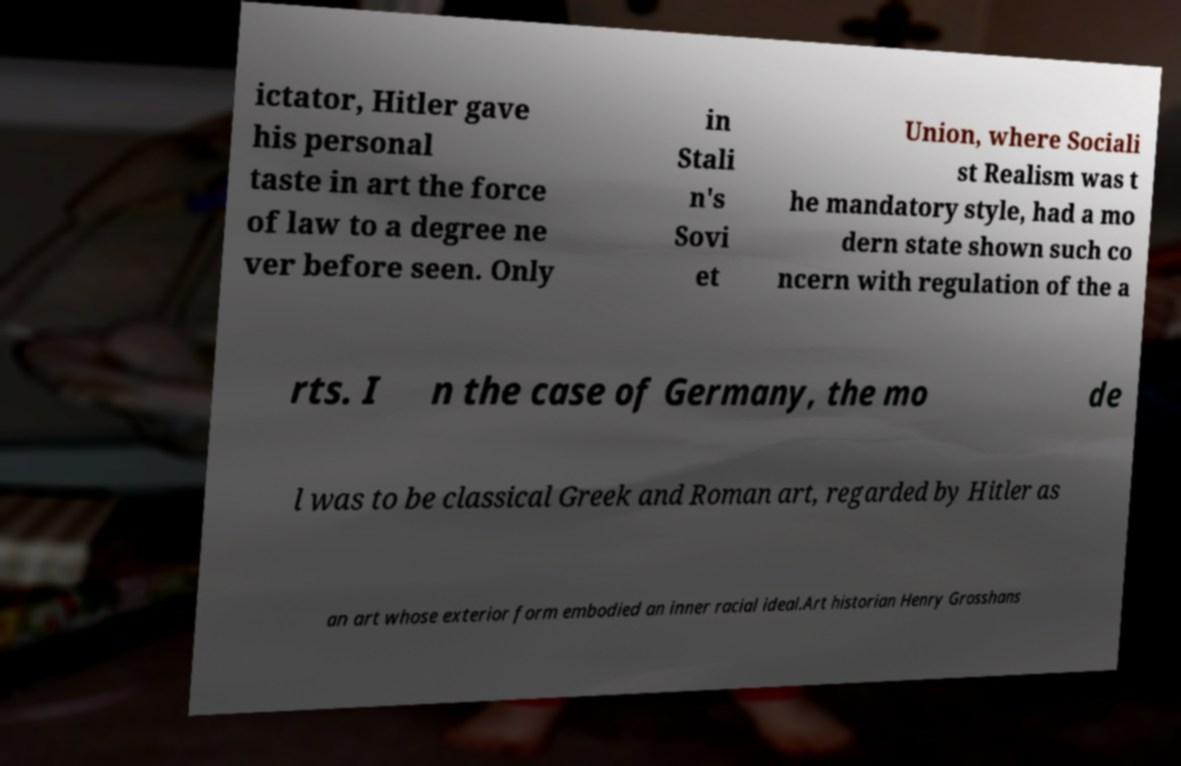What messages or text are displayed in this image? I need them in a readable, typed format. ictator, Hitler gave his personal taste in art the force of law to a degree ne ver before seen. Only in Stali n's Sovi et Union, where Sociali st Realism was t he mandatory style, had a mo dern state shown such co ncern with regulation of the a rts. I n the case of Germany, the mo de l was to be classical Greek and Roman art, regarded by Hitler as an art whose exterior form embodied an inner racial ideal.Art historian Henry Grosshans 